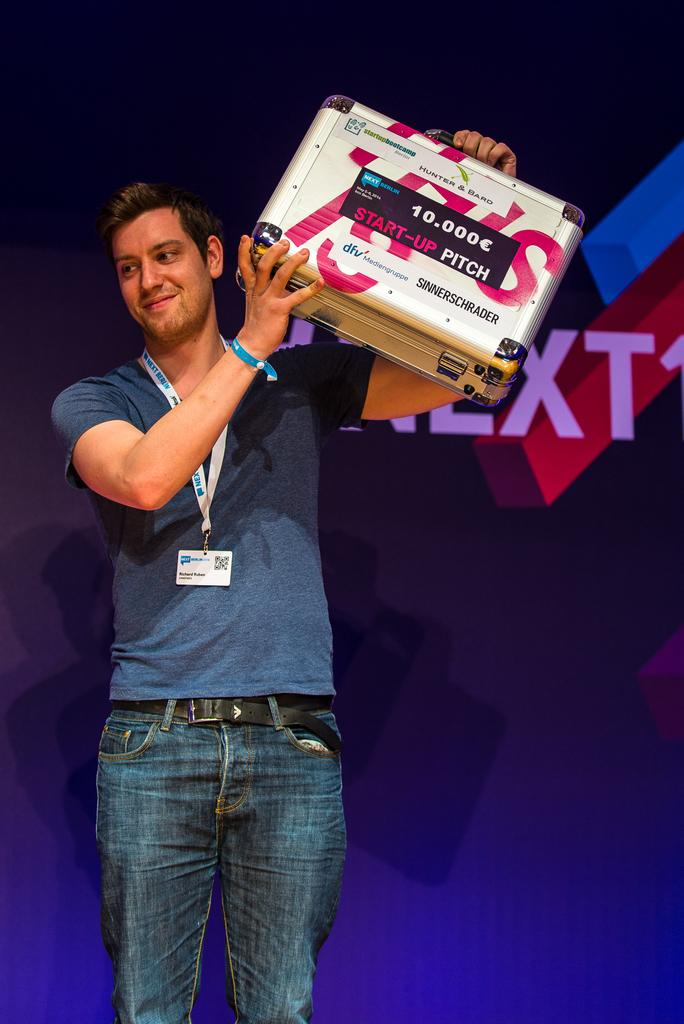What is the person in the image doing? The person is standing in the image. What object is the person holding? The person is holding a briefcase. What can be seen in the background of the image? There is a board in the background of the image. Where is the quiver located in the image? There is no quiver present in the image. What type of shelf can be seen in the image? There is no shelf present in the image. 